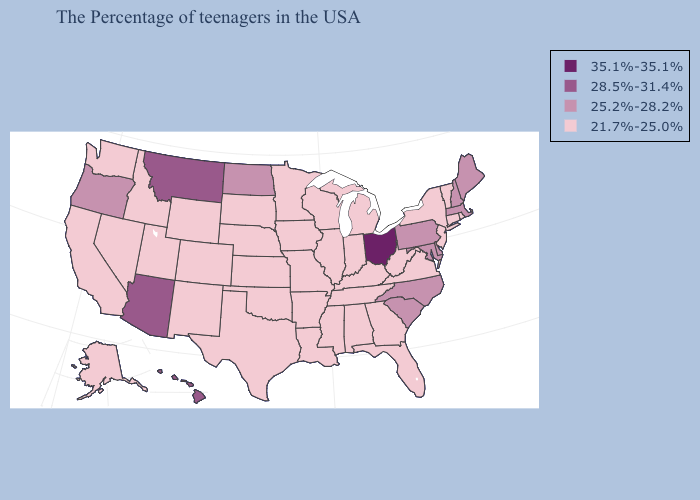Does Alaska have the lowest value in the USA?
Quick response, please. Yes. What is the highest value in states that border Texas?
Be succinct. 21.7%-25.0%. Name the states that have a value in the range 25.2%-28.2%?
Quick response, please. Maine, Massachusetts, New Hampshire, Delaware, Maryland, Pennsylvania, North Carolina, South Carolina, North Dakota, Oregon. What is the lowest value in the South?
Quick response, please. 21.7%-25.0%. Does the map have missing data?
Write a very short answer. No. Name the states that have a value in the range 35.1%-35.1%?
Keep it brief. Ohio. What is the value of Delaware?
Short answer required. 25.2%-28.2%. Among the states that border Colorado , does Arizona have the highest value?
Give a very brief answer. Yes. Does the first symbol in the legend represent the smallest category?
Keep it brief. No. What is the value of Colorado?
Write a very short answer. 21.7%-25.0%. Does Hawaii have the highest value in the West?
Keep it brief. Yes. What is the value of South Carolina?
Answer briefly. 25.2%-28.2%. Which states have the lowest value in the USA?
Give a very brief answer. Rhode Island, Vermont, Connecticut, New York, New Jersey, Virginia, West Virginia, Florida, Georgia, Michigan, Kentucky, Indiana, Alabama, Tennessee, Wisconsin, Illinois, Mississippi, Louisiana, Missouri, Arkansas, Minnesota, Iowa, Kansas, Nebraska, Oklahoma, Texas, South Dakota, Wyoming, Colorado, New Mexico, Utah, Idaho, Nevada, California, Washington, Alaska. What is the value of Nebraska?
Keep it brief. 21.7%-25.0%. Which states hav the highest value in the MidWest?
Quick response, please. Ohio. 